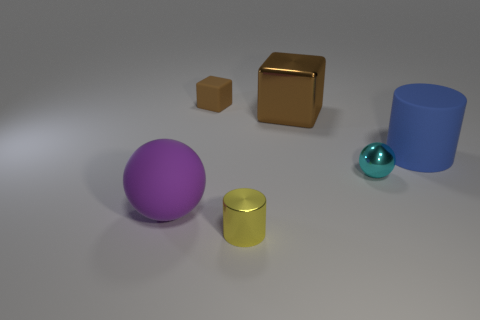Add 1 tiny brown rubber things. How many objects exist? 7 Subtract all cubes. How many objects are left? 4 Add 6 matte things. How many matte things exist? 9 Subtract 0 yellow balls. How many objects are left? 6 Subtract all big yellow cubes. Subtract all small cyan spheres. How many objects are left? 5 Add 2 big shiny cubes. How many big shiny cubes are left? 3 